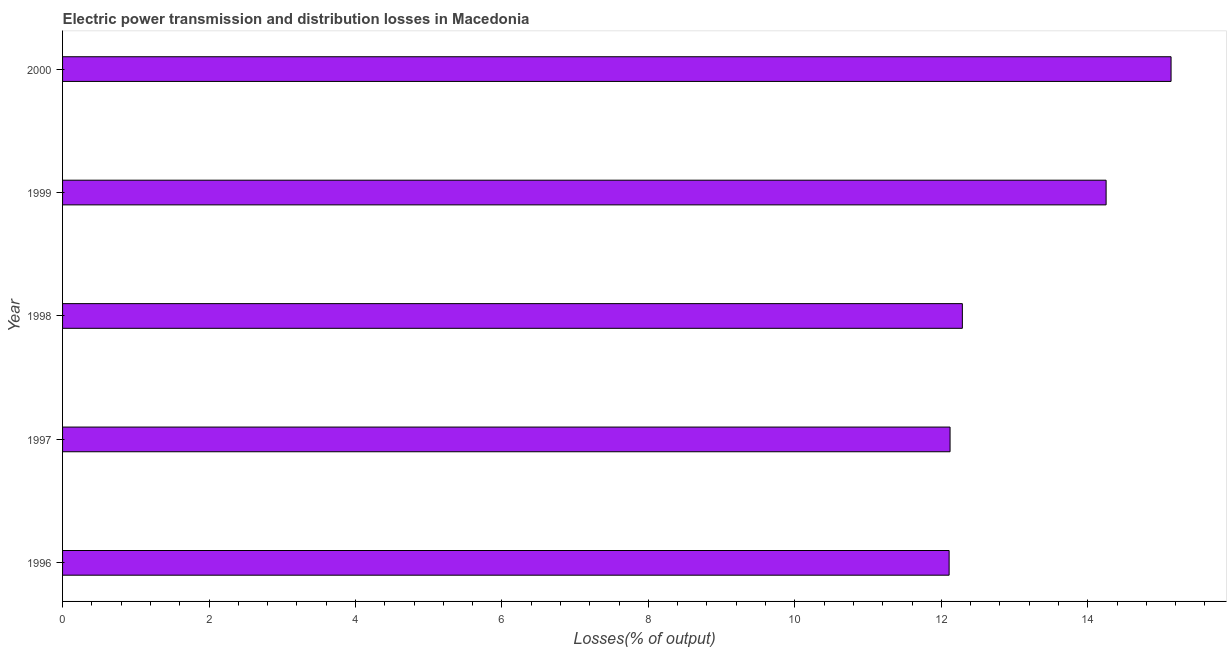Does the graph contain grids?
Your response must be concise. No. What is the title of the graph?
Offer a very short reply. Electric power transmission and distribution losses in Macedonia. What is the label or title of the X-axis?
Your response must be concise. Losses(% of output). What is the label or title of the Y-axis?
Your answer should be compact. Year. What is the electric power transmission and distribution losses in 2000?
Give a very brief answer. 15.14. Across all years, what is the maximum electric power transmission and distribution losses?
Offer a very short reply. 15.14. Across all years, what is the minimum electric power transmission and distribution losses?
Provide a succinct answer. 12.11. What is the sum of the electric power transmission and distribution losses?
Your answer should be compact. 65.9. What is the difference between the electric power transmission and distribution losses in 1997 and 1999?
Give a very brief answer. -2.13. What is the average electric power transmission and distribution losses per year?
Offer a very short reply. 13.18. What is the median electric power transmission and distribution losses?
Offer a terse response. 12.29. In how many years, is the electric power transmission and distribution losses greater than 2.4 %?
Keep it short and to the point. 5. What is the ratio of the electric power transmission and distribution losses in 1997 to that in 2000?
Ensure brevity in your answer.  0.8. Is the electric power transmission and distribution losses in 1997 less than that in 1999?
Your answer should be very brief. Yes. Is the difference between the electric power transmission and distribution losses in 1998 and 2000 greater than the difference between any two years?
Ensure brevity in your answer.  No. What is the difference between the highest and the second highest electric power transmission and distribution losses?
Give a very brief answer. 0.89. What is the difference between the highest and the lowest electric power transmission and distribution losses?
Provide a succinct answer. 3.03. Are all the bars in the graph horizontal?
Provide a succinct answer. Yes. How many years are there in the graph?
Give a very brief answer. 5. Are the values on the major ticks of X-axis written in scientific E-notation?
Provide a short and direct response. No. What is the Losses(% of output) in 1996?
Keep it short and to the point. 12.11. What is the Losses(% of output) in 1997?
Your answer should be compact. 12.12. What is the Losses(% of output) in 1998?
Make the answer very short. 12.29. What is the Losses(% of output) in 1999?
Your response must be concise. 14.25. What is the Losses(% of output) of 2000?
Ensure brevity in your answer.  15.14. What is the difference between the Losses(% of output) in 1996 and 1997?
Give a very brief answer. -0.01. What is the difference between the Losses(% of output) in 1996 and 1998?
Offer a very short reply. -0.18. What is the difference between the Losses(% of output) in 1996 and 1999?
Provide a succinct answer. -2.14. What is the difference between the Losses(% of output) in 1996 and 2000?
Make the answer very short. -3.03. What is the difference between the Losses(% of output) in 1997 and 1998?
Your answer should be compact. -0.17. What is the difference between the Losses(% of output) in 1997 and 1999?
Give a very brief answer. -2.13. What is the difference between the Losses(% of output) in 1997 and 2000?
Keep it short and to the point. -3.02. What is the difference between the Losses(% of output) in 1998 and 1999?
Ensure brevity in your answer.  -1.96. What is the difference between the Losses(% of output) in 1998 and 2000?
Your answer should be compact. -2.85. What is the difference between the Losses(% of output) in 1999 and 2000?
Keep it short and to the point. -0.89. What is the ratio of the Losses(% of output) in 1996 to that in 1997?
Give a very brief answer. 1. What is the ratio of the Losses(% of output) in 1996 to that in 1998?
Ensure brevity in your answer.  0.98. What is the ratio of the Losses(% of output) in 1996 to that in 1999?
Your answer should be very brief. 0.85. What is the ratio of the Losses(% of output) in 1997 to that in 1998?
Ensure brevity in your answer.  0.99. What is the ratio of the Losses(% of output) in 1997 to that in 2000?
Give a very brief answer. 0.8. What is the ratio of the Losses(% of output) in 1998 to that in 1999?
Give a very brief answer. 0.86. What is the ratio of the Losses(% of output) in 1998 to that in 2000?
Keep it short and to the point. 0.81. What is the ratio of the Losses(% of output) in 1999 to that in 2000?
Your answer should be compact. 0.94. 